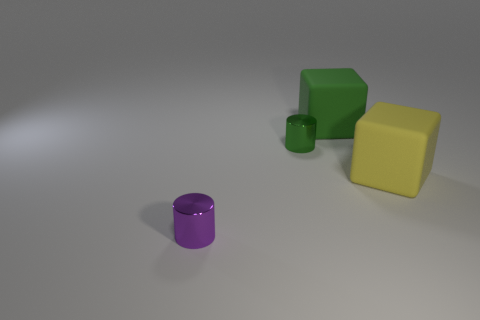There is a yellow rubber thing that is the same shape as the large green object; what size is it?
Your answer should be very brief. Large. Is there any other thing that has the same material as the purple cylinder?
Make the answer very short. Yes. There is a yellow object behind the tiny purple metal object; is it the same size as the shiny thing behind the tiny purple metallic object?
Provide a short and direct response. No. How many tiny things are either purple objects or rubber cubes?
Provide a short and direct response. 1. How many things are both left of the green shiny object and right of the small purple metal cylinder?
Your response must be concise. 0. Is the tiny green cylinder made of the same material as the block that is to the left of the large yellow matte thing?
Keep it short and to the point. No. What number of purple things are either tiny things or large blocks?
Your answer should be very brief. 1. Are there any other green matte things that have the same size as the green rubber thing?
Make the answer very short. No. What material is the small thing behind the tiny cylinder that is in front of the shiny object behind the tiny purple cylinder made of?
Offer a very short reply. Metal. Are there the same number of yellow rubber objects that are in front of the large green matte block and big red shiny things?
Make the answer very short. No. 